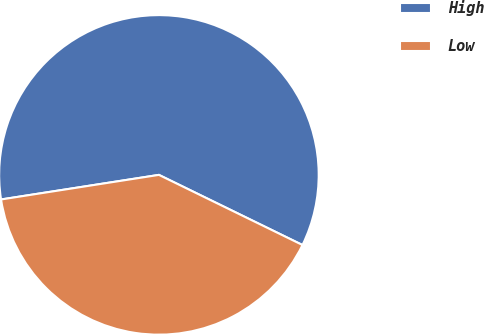Convert chart to OTSL. <chart><loc_0><loc_0><loc_500><loc_500><pie_chart><fcel>High<fcel>Low<nl><fcel>59.69%<fcel>40.31%<nl></chart> 